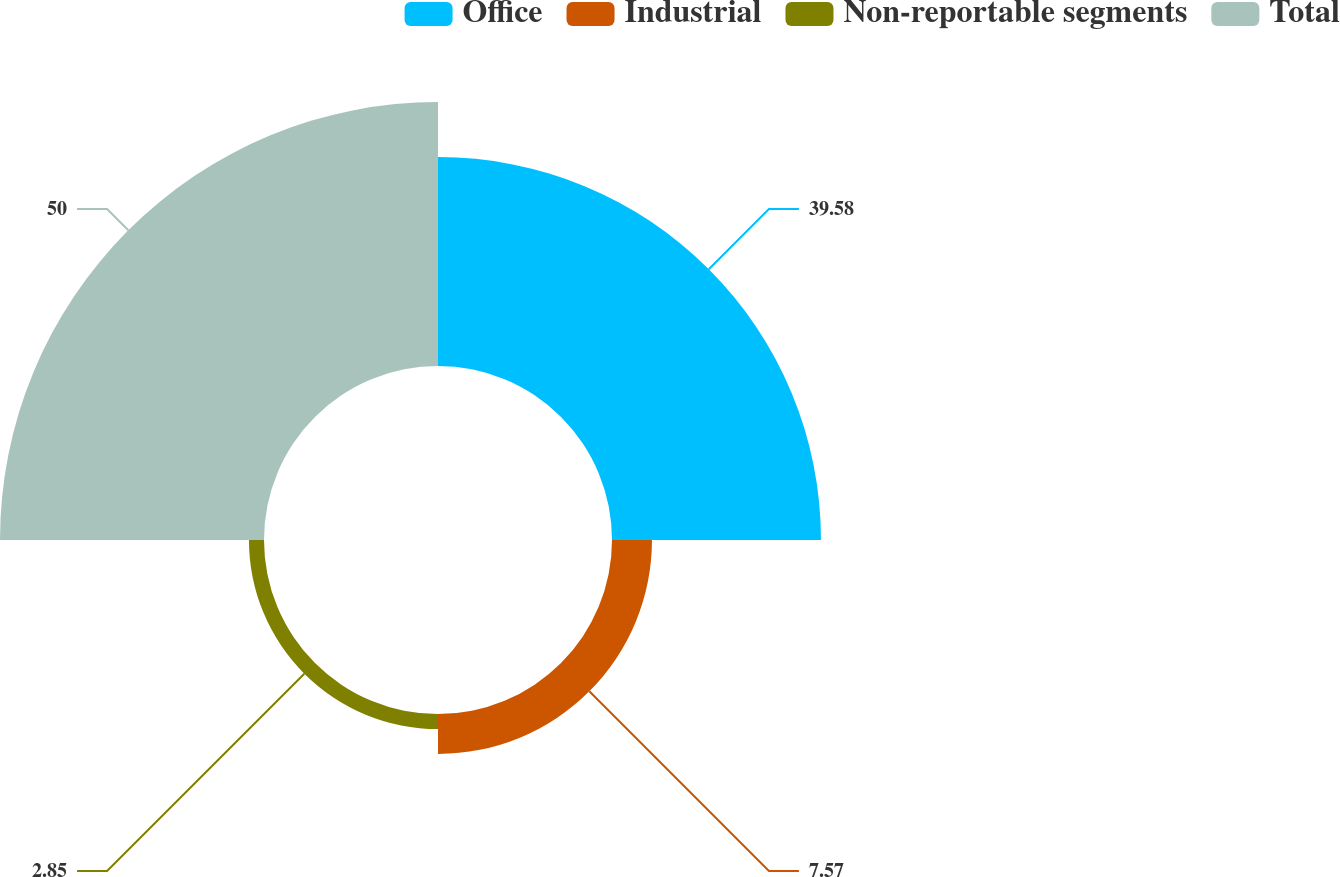Convert chart to OTSL. <chart><loc_0><loc_0><loc_500><loc_500><pie_chart><fcel>Office<fcel>Industrial<fcel>Non-reportable segments<fcel>Total<nl><fcel>39.58%<fcel>7.57%<fcel>2.85%<fcel>50.0%<nl></chart> 